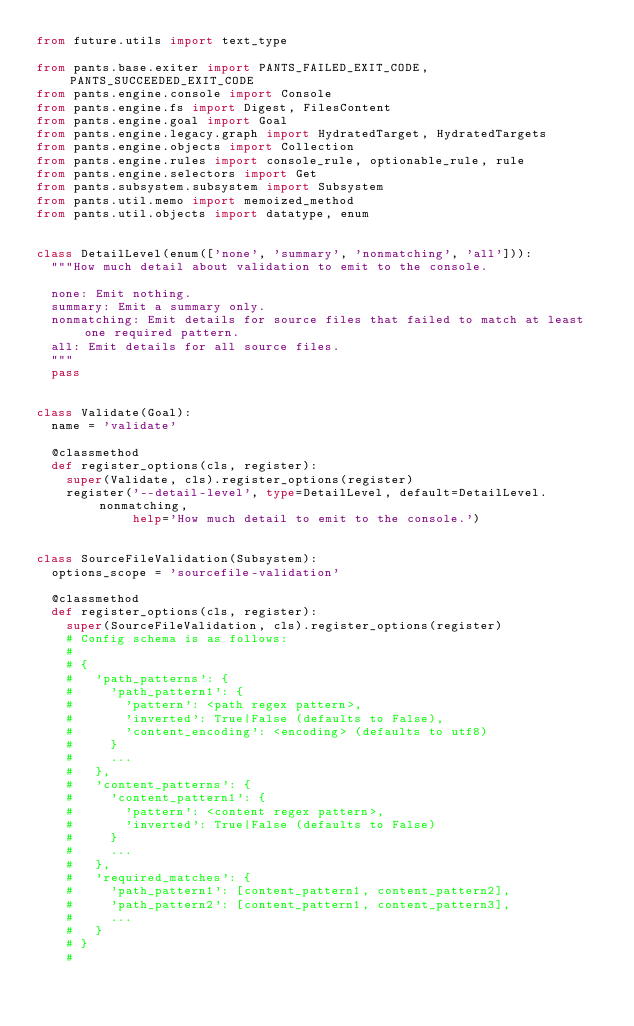<code> <loc_0><loc_0><loc_500><loc_500><_Python_>from future.utils import text_type

from pants.base.exiter import PANTS_FAILED_EXIT_CODE, PANTS_SUCCEEDED_EXIT_CODE
from pants.engine.console import Console
from pants.engine.fs import Digest, FilesContent
from pants.engine.goal import Goal
from pants.engine.legacy.graph import HydratedTarget, HydratedTargets
from pants.engine.objects import Collection
from pants.engine.rules import console_rule, optionable_rule, rule
from pants.engine.selectors import Get
from pants.subsystem.subsystem import Subsystem
from pants.util.memo import memoized_method
from pants.util.objects import datatype, enum


class DetailLevel(enum(['none', 'summary', 'nonmatching', 'all'])):
  """How much detail about validation to emit to the console.

  none: Emit nothing.
  summary: Emit a summary only.
  nonmatching: Emit details for source files that failed to match at least one required pattern.
  all: Emit details for all source files.
  """
  pass


class Validate(Goal):
  name = 'validate'

  @classmethod
  def register_options(cls, register):
    super(Validate, cls).register_options(register)
    register('--detail-level', type=DetailLevel, default=DetailLevel.nonmatching,
             help='How much detail to emit to the console.')


class SourceFileValidation(Subsystem):
  options_scope = 'sourcefile-validation'

  @classmethod
  def register_options(cls, register):
    super(SourceFileValidation, cls).register_options(register)
    # Config schema is as follows:
    #
    # {
    #   'path_patterns': {
    #     'path_pattern1': {
    #       'pattern': <path regex pattern>,
    #       'inverted': True|False (defaults to False),
    #       'content_encoding': <encoding> (defaults to utf8)
    #     }
    #     ...
    #   },
    #   'content_patterns': {
    #     'content_pattern1': {
    #       'pattern': <content regex pattern>,
    #       'inverted': True|False (defaults to False)
    #     }
    #     ...
    #   },
    #   'required_matches': {
    #     'path_pattern1': [content_pattern1, content_pattern2],
    #     'path_pattern2': [content_pattern1, content_pattern3],
    #     ...
    #   }
    # }
    #</code> 